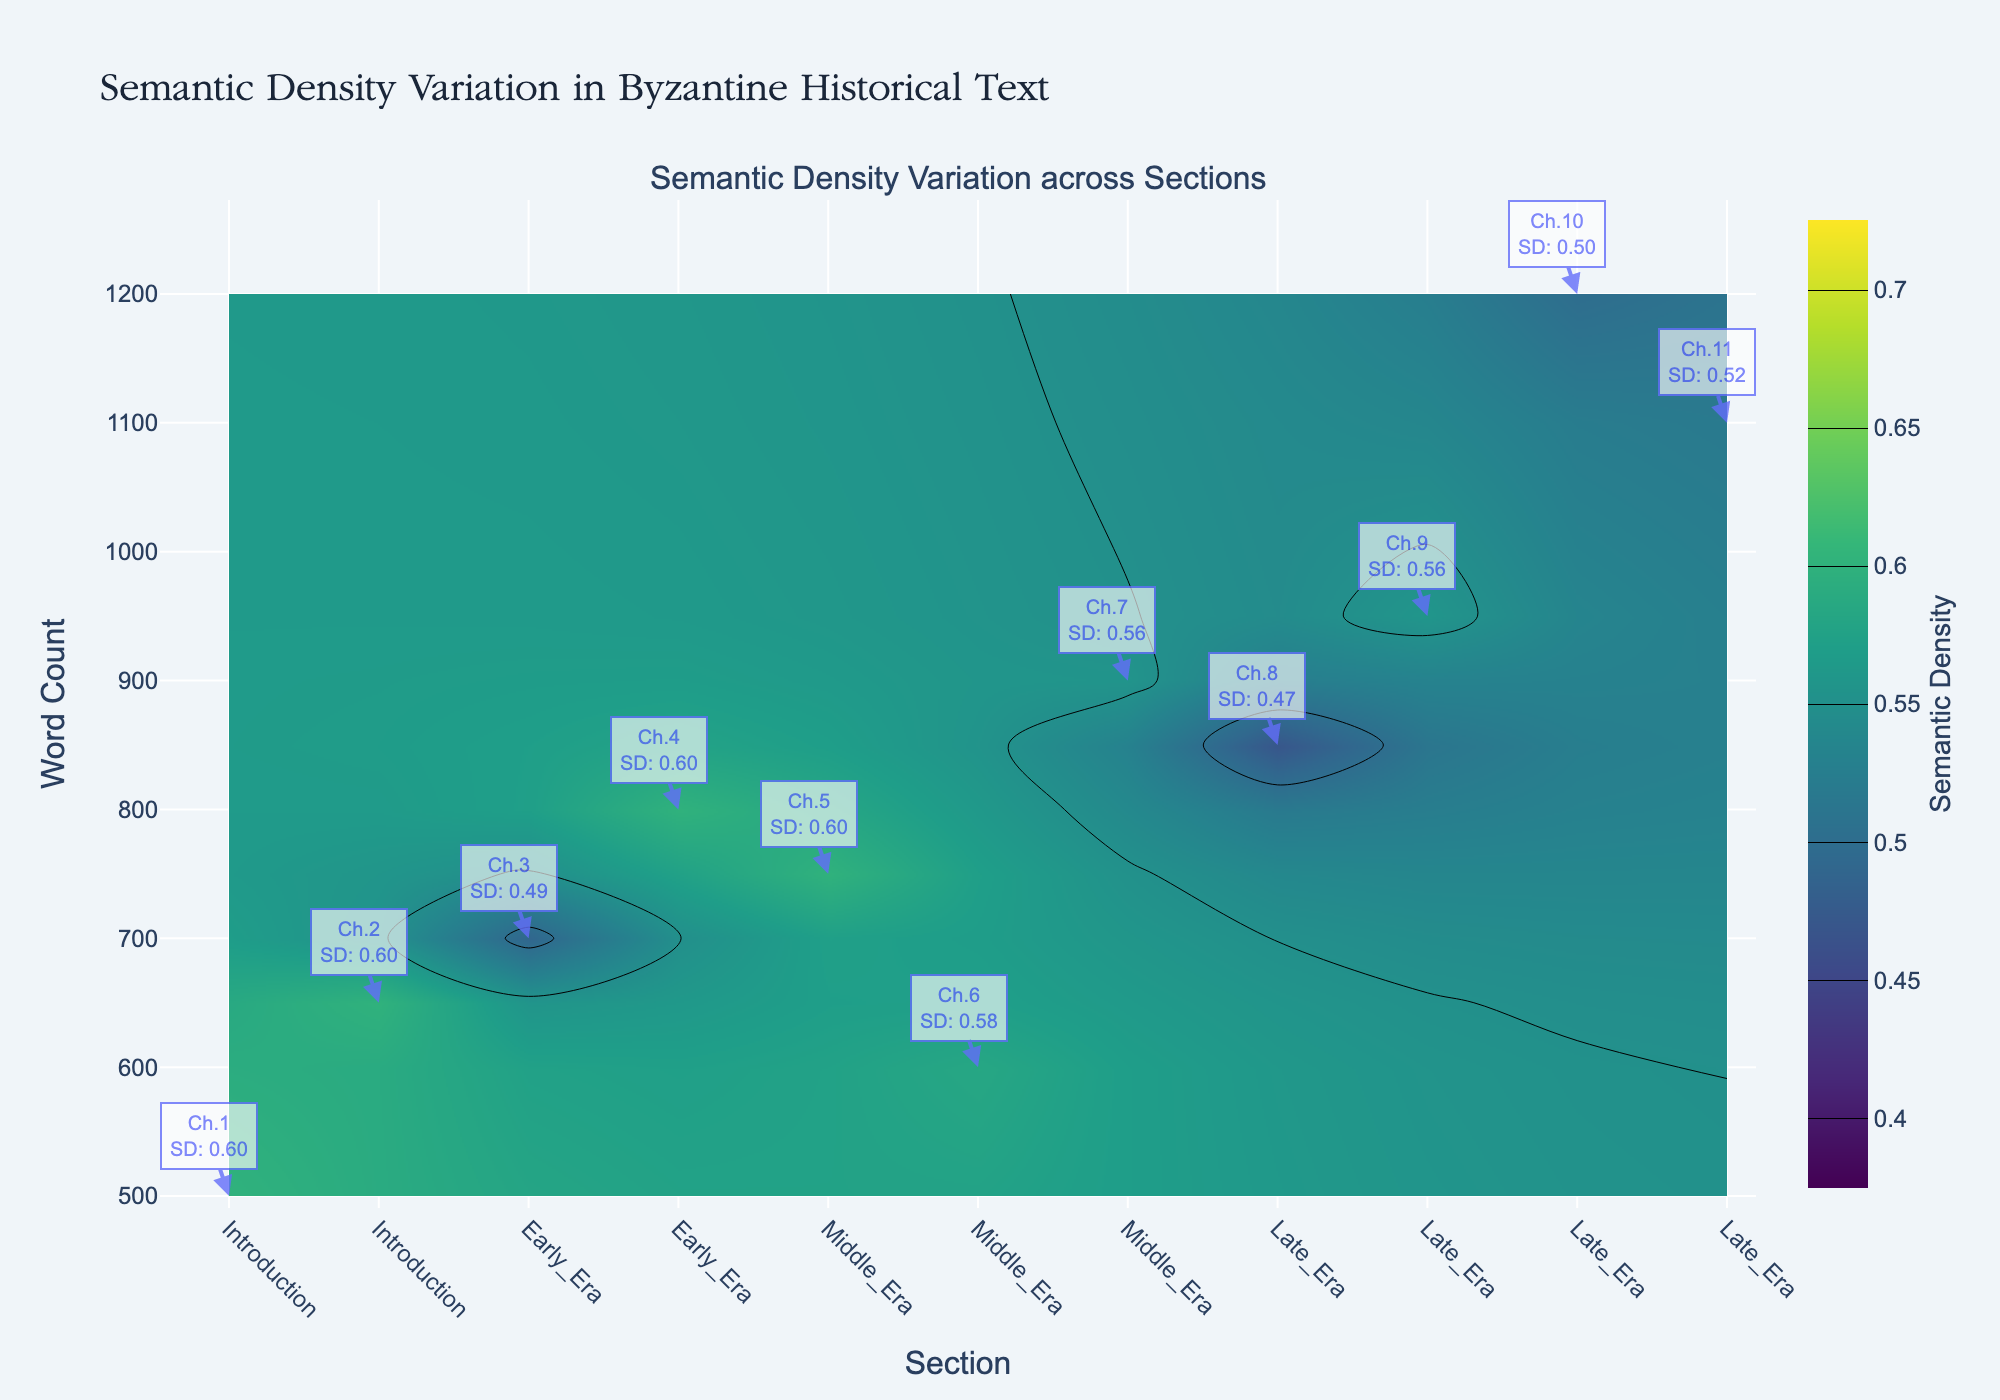which section has the highest semantic density? To determine the section with the highest semantic density, observe the color gradients on the contour plot. The highest semantic density values are usually indicated by the darkest colors on the 'Viridis' scale, which should be around 0.6 to 0.7. By checking the annotations, it appears that multiple chapters in the 'Introduction' section reach a density of 0.6.
Answer: Introduction which section has the lowest semantic density? To find the section with the lowest semantic density, look for the lightest colors on the contour plot. According to the annotations, Chapter 8 in the 'Late_Era' has a semantic density of 0.47, which is the lowest among all chapters.
Answer: Late_Era what is the word count of the chapter with the lowest semantic density? According to the annotation, Chapter 8 in the 'Late_Era' has a semantic density of 0.47. By locating this chapter on the y-axis, it aligns with a word count of 850.
Answer: 850 how does the semantic density in the 'Middle_Era' section vary across its chapters? The 'Middle_Era' section comprises chapters 5 to 7. From the contour plot, all chapters in this section have a semantic density between 0.556 and 0.6. Chapter 7 shows the lowest semantic density at 0.556, while Chapters 5 and 6 have higher densities at 0.6 and 0.583 respectively.
Answer: Varied between 0.556 and 0.6 which chapter has the highest word count, and what is its semantic density? Locate the highest point on the y-axis to identify the chapter with the highest word count. Chapter 10 in the 'Late_Era' section has the highest word count at 1200. The associated annotation indicates a semantic density of 0.5.
Answer: Chapter 10, 0.5 which section shows the most consistent semantic density across all its chapters? Consistent semantic density means minimal variation across chapters within a section. By examining the color uniformity in the contour plot, the 'Introduction' section stands out as it maintains a semantic density around 0.6 in both chapters.
Answer: Introduction how do the word count ranges compare between 'Early_Era' and 'Late_Era' sections? The 'Early_Era' section includes word counts of 700 and 800, whereas the 'Late_Era' contains word counts from 850 to 1200. 'Late_Era' has a broader range and generally higher word counts than 'Early_Era'.
Answer: 'Late_Era' has a broader and higher range of word counts what is the average semantic density of the 'Late_Era' section? The 'Late_Era' section includes Chapters 8 to 11 with semantic densities of 0.47, 0.558, 0.5, and 0.518 respectively. The average is calculated as (0.47 + 0.558 + 0.5 + 0.518) / 4 = 2.046 / 4 ≈ 0.5115
Answer: 0.5115 compare the semantic density between chapters with the highest and lowest word counts. The highest word count chapter is Chapter 10 (1200 words) with a semantic density of 0.5. The lowest word count chapter is Chapter 1 (500 words) with a semantic density of 0.6. Therefore, Chapter 1 has a higher semantic density than Chapter 10.
Answer: Chapter 1 has a higher semantic density what does the color scale represent in the contour plot? The 'Viridis' color scale on the contour plot represents varying levels of semantic density. Darker colors indicate higher semantic density values, while lighter colors indicate lower values.
Answer: Semantic Density 